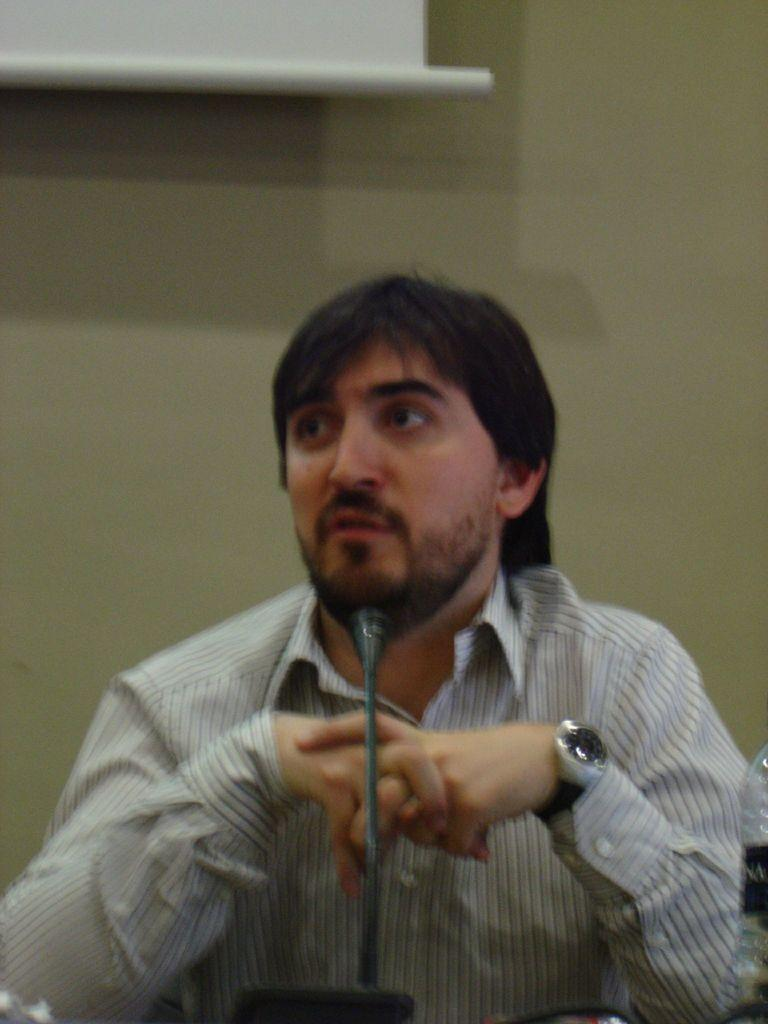What is the main subject of the image? There is a person in the image. What is the person wearing? The person is wearing a shirt. What is the person doing in the image? The person is sitting in front of a microphone and speaking. What other objects can be seen in the image? There is a bottle, a screen, and a wall in the background of the image. What type of insurance policy is the beggar selling in the image? There is no beggar present in the image, nor is there any mention of insurance policies. 